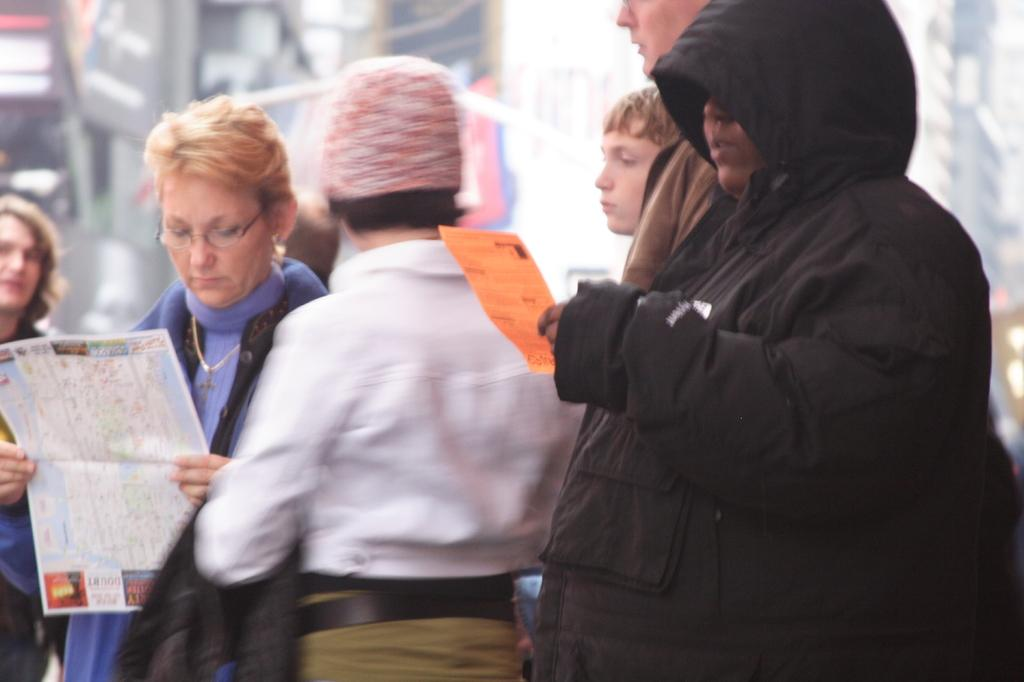What can be seen in the image? There are people in the image. What are two of the people doing? Two of the people are holding papers. Can you describe the background of the image? The background of the image is blurry. What type of prose is being read by the people in the image? There is no indication in the image that the people are reading any prose, as the focus is on them holding papers. 